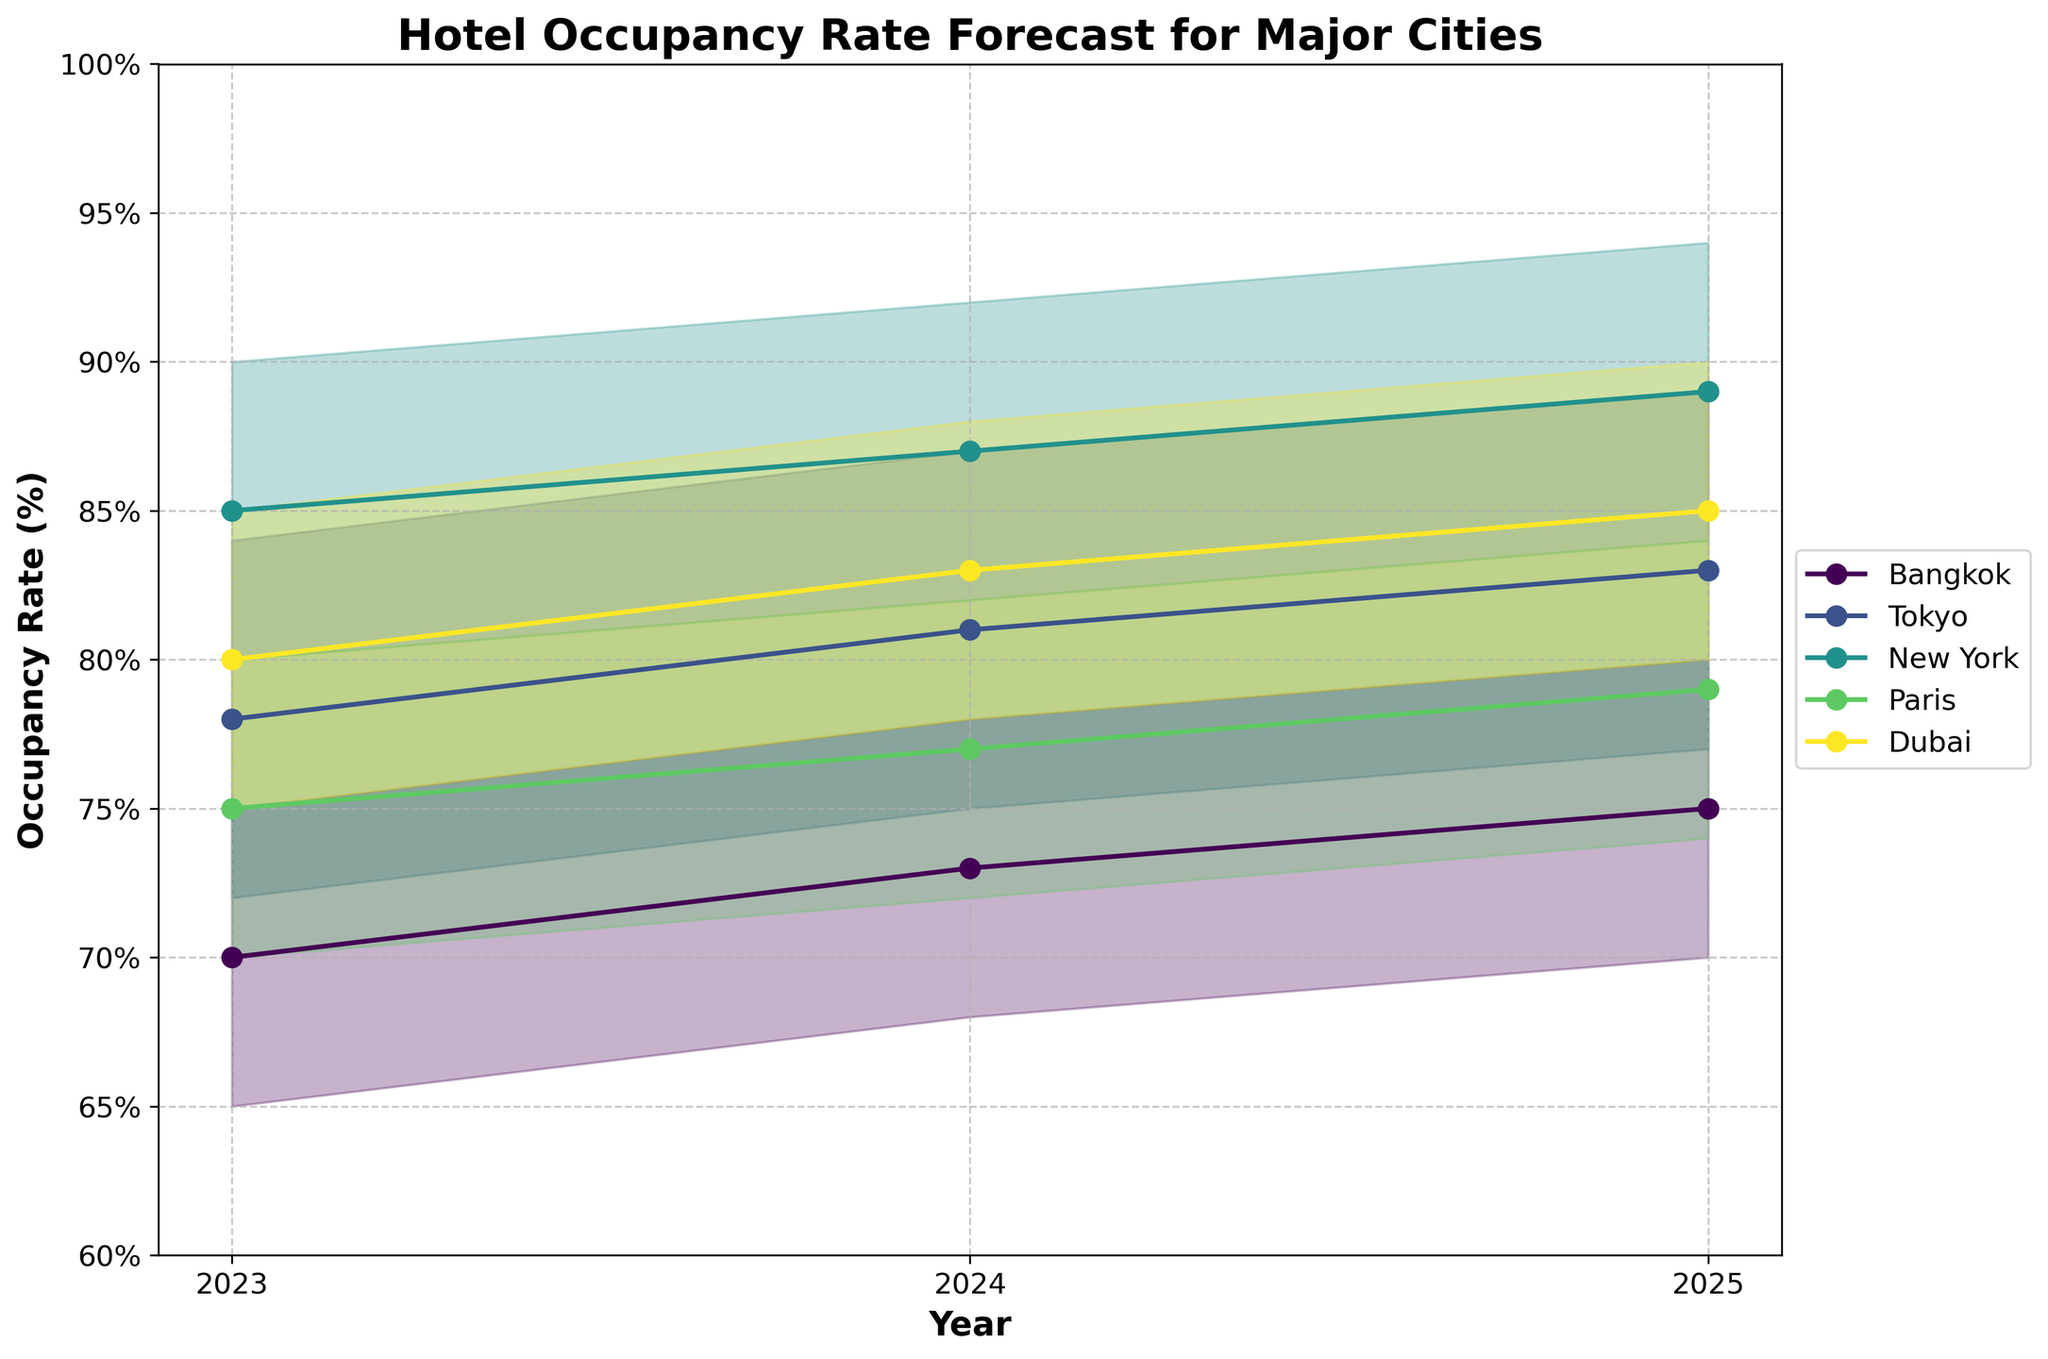What is the title of the chart? The title is typically displayed at the top of the chart and provides a quick summary of the content that the chart covers. In this case, looking at the chart from the information provided, the title indicates what the visual data represents.
Answer: Hotel Occupancy Rate Forecast for Major Cities Which city has the highest mid-estimate occupancy rate in 2025? To find the highest mid-estimate occupancy rate for 2025, look at the data points for the mid-estimate values for each city in the year 2025 and compare them to determine which is the highest.
Answer: New York In 2024, which city has the lowest low-estimate forecast for occupancy rates? To determine the lowest low-estimate forecast for 2024, compare the low-estimate values of all cities for the year 2024 and identify the smallest value.
Answer: Paris How does the mid-estimate for Bangkok's occupancy rate change from 2023 to 2025? Calculate the difference between the mid-estimate values for Bangkok in 2023 and 2025. Subtract the mid-estimate value for 2023 from the one for 2025.
Answer: Increases by 5% Which city shows the largest range (difference between high and low estimates) in 2024? To find the largest range, calculate the difference between the high and low estimates for each city in 2024, then identify which city has the largest range.
Answer: Tokyo What is the average mid-estimate for Tokyo's occupancy rates over the three years? To find the average mid-estimate for Tokyo from 2023 to 2025, sum up the mid-estimate values for each year and divide by the number of years (3).
Answer: 80.67% Compare the high-estimate of New York in 2023 with the low-estimate of New York in 2025. Which is higher? This involves simply comparing the two estimates for New York: the high-estimate in 2023 and the low-estimate in 2025.
Answer: High-estimate in 2023 Which city and year combination has the mid-estimate closest to 80%? Look at the mid-estimate values for all city and year combinations and identify the one closest to 80%.
Answer: Dubai 2023 Across all cities, which year consistently shows an increase in mid-estimate from the previous year? To identify the year with consistent increases in mid-estimates, compare the mid-estimate values for each city year by year and see if each city's value increases.
Answer: 2024 In 2025, which city has the most narrow spread between low and high estimates? Calculate the spread by finding the difference between low and high estimates for each city in 2025, then compare these spreads to see which is the smallest.
Answer: Paris 